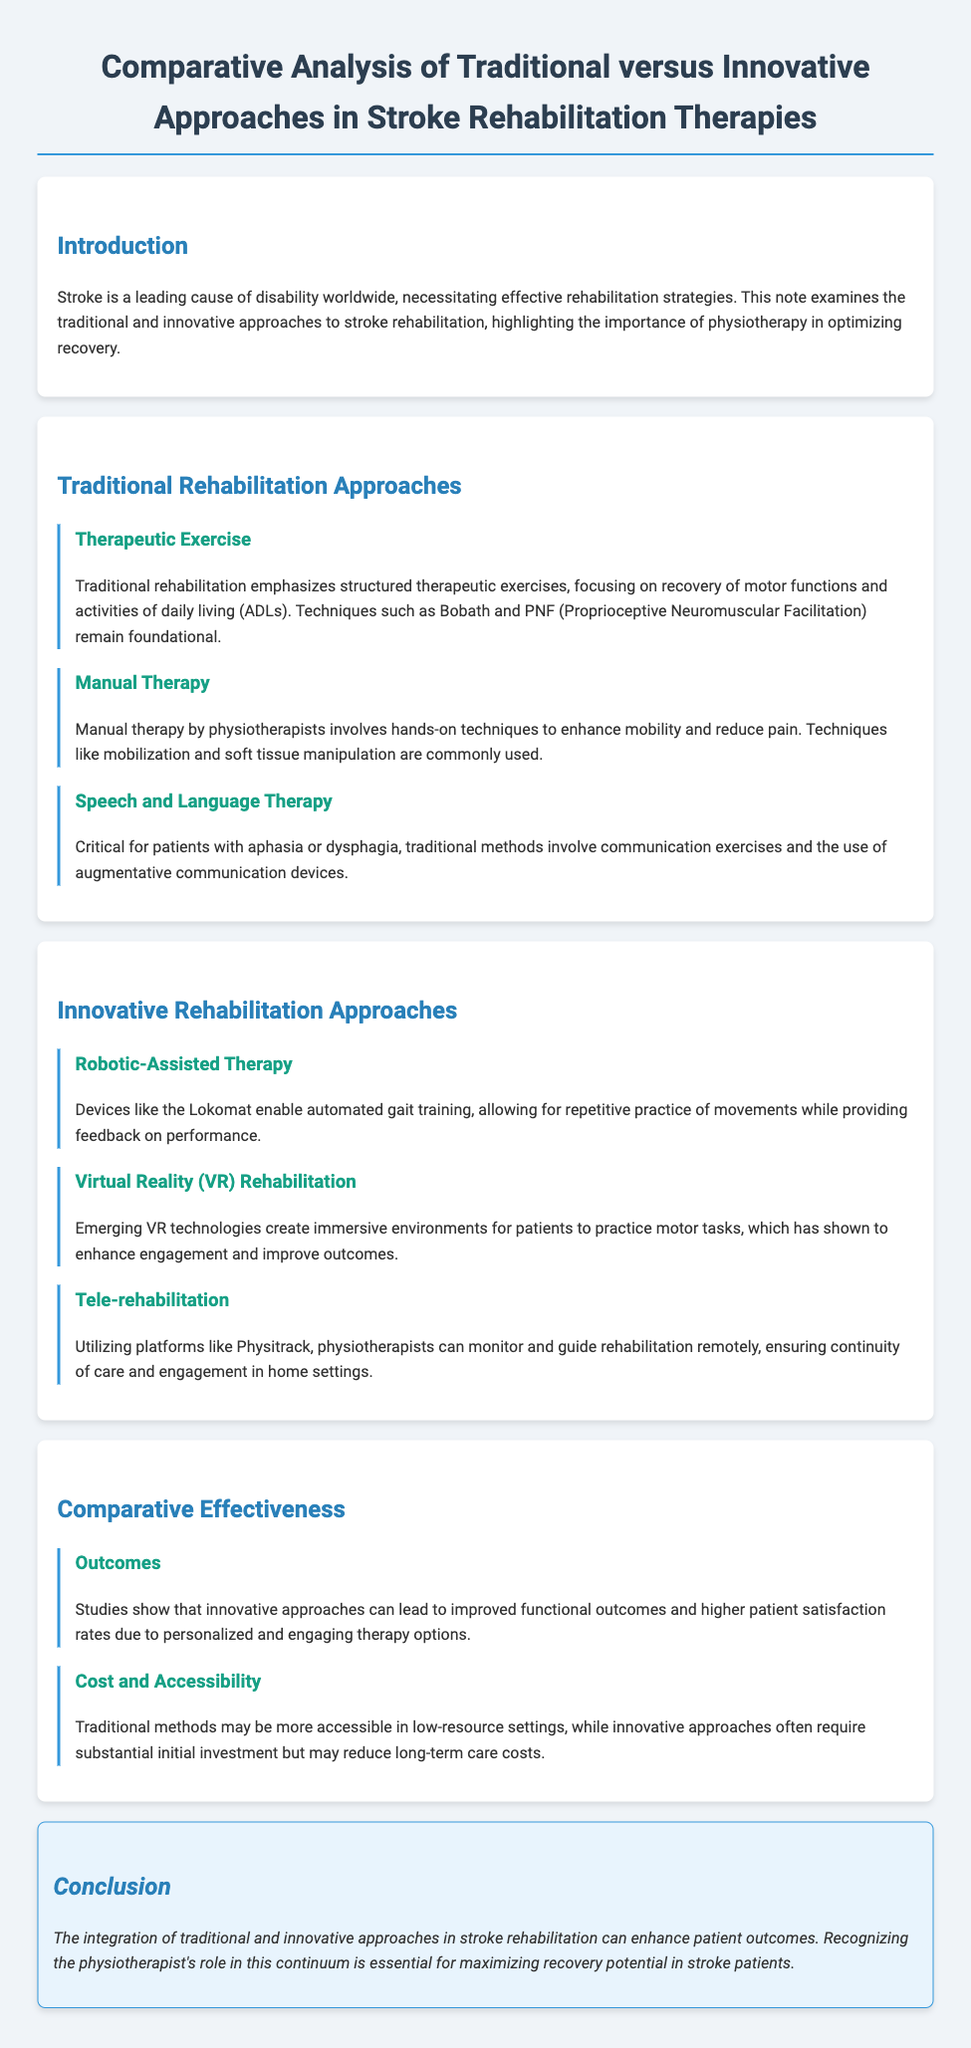What is a leading cause of disability worldwide? The document states that stroke is a leading cause of disability worldwide, indicating its prevalence and impact on individuals.
Answer: stroke What therapeutic technique is foundational in traditional rehabilitation? The document mentions Bobath and PNF as foundational techniques in traditional rehabilitation methods.
Answer: Bobath and PNF What technology is used for automated gait training? The document references devices like the Lokomat used in robotic-assisted therapy for gait training.
Answer: Lokomat Which innovative approach utilizes immersive environments? The document discusses emerging VR technologies that create immersive environments for patients.
Answer: Virtual Reality (VR) Rehabilitation What is the primary focus of traditional therapeutic exercise? The document states that traditional rehabilitation focuses on recovery of motor functions and activities of daily living (ADLs).
Answer: recovery of motor functions and activities of daily living (ADLs) What method may reduce long-term care costs according to the document? The document indicates that innovative approaches, although requiring substantial initial investment, may reduce long-term care costs.
Answer: innovative approaches What role does the physiotherapist play in stroke rehabilitation? The conclusion emphasizes the importance of recognizing the physiotherapist's role in maximizing recovery potential in stroke patients.
Answer: maximizing recovery potential Which approach is mentioned for remote monitoring of rehabilitation? The document mentions tele-rehabilitation utilizing platforms like Physitrack for remote monitoring of rehabilitation.
Answer: tele-rehabilitation What benefit do innovative approaches provide in stroke rehabilitation? The document states that innovative approaches can lead to improved functional outcomes and higher patient satisfaction rates.
Answer: improved functional outcomes and higher patient satisfaction rates 